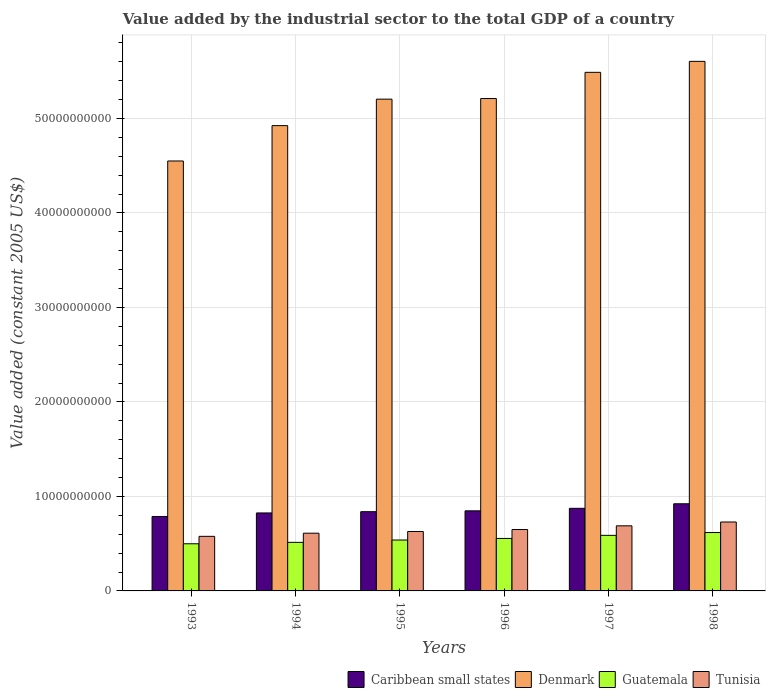How many groups of bars are there?
Provide a succinct answer. 6. Are the number of bars on each tick of the X-axis equal?
Provide a short and direct response. Yes. What is the label of the 2nd group of bars from the left?
Give a very brief answer. 1994. What is the value added by the industrial sector in Tunisia in 1998?
Give a very brief answer. 7.29e+09. Across all years, what is the maximum value added by the industrial sector in Guatemala?
Your response must be concise. 6.18e+09. Across all years, what is the minimum value added by the industrial sector in Guatemala?
Your response must be concise. 4.99e+09. In which year was the value added by the industrial sector in Tunisia maximum?
Give a very brief answer. 1998. What is the total value added by the industrial sector in Guatemala in the graph?
Your answer should be very brief. 3.31e+1. What is the difference between the value added by the industrial sector in Caribbean small states in 1994 and that in 1998?
Give a very brief answer. -9.70e+08. What is the difference between the value added by the industrial sector in Caribbean small states in 1994 and the value added by the industrial sector in Denmark in 1995?
Ensure brevity in your answer.  -4.38e+1. What is the average value added by the industrial sector in Tunisia per year?
Provide a short and direct response. 6.48e+09. In the year 1994, what is the difference between the value added by the industrial sector in Tunisia and value added by the industrial sector in Guatemala?
Ensure brevity in your answer.  9.70e+08. In how many years, is the value added by the industrial sector in Caribbean small states greater than 18000000000 US$?
Your response must be concise. 0. What is the ratio of the value added by the industrial sector in Tunisia in 1994 to that in 1997?
Offer a very short reply. 0.89. Is the value added by the industrial sector in Caribbean small states in 1994 less than that in 1995?
Offer a very short reply. Yes. Is the difference between the value added by the industrial sector in Tunisia in 1994 and 1995 greater than the difference between the value added by the industrial sector in Guatemala in 1994 and 1995?
Make the answer very short. Yes. What is the difference between the highest and the second highest value added by the industrial sector in Caribbean small states?
Ensure brevity in your answer.  4.80e+08. What is the difference between the highest and the lowest value added by the industrial sector in Guatemala?
Your answer should be compact. 1.19e+09. Is the sum of the value added by the industrial sector in Caribbean small states in 1995 and 1996 greater than the maximum value added by the industrial sector in Guatemala across all years?
Ensure brevity in your answer.  Yes. Is it the case that in every year, the sum of the value added by the industrial sector in Denmark and value added by the industrial sector in Guatemala is greater than the sum of value added by the industrial sector in Tunisia and value added by the industrial sector in Caribbean small states?
Give a very brief answer. Yes. What does the 1st bar from the left in 1993 represents?
Ensure brevity in your answer.  Caribbean small states. Is it the case that in every year, the sum of the value added by the industrial sector in Guatemala and value added by the industrial sector in Caribbean small states is greater than the value added by the industrial sector in Denmark?
Ensure brevity in your answer.  No. How many bars are there?
Your answer should be very brief. 24. What is the difference between two consecutive major ticks on the Y-axis?
Ensure brevity in your answer.  1.00e+1. How are the legend labels stacked?
Give a very brief answer. Horizontal. What is the title of the graph?
Your response must be concise. Value added by the industrial sector to the total GDP of a country. What is the label or title of the X-axis?
Keep it short and to the point. Years. What is the label or title of the Y-axis?
Keep it short and to the point. Value added (constant 2005 US$). What is the Value added (constant 2005 US$) of Caribbean small states in 1993?
Your answer should be very brief. 7.88e+09. What is the Value added (constant 2005 US$) in Denmark in 1993?
Your answer should be very brief. 4.55e+1. What is the Value added (constant 2005 US$) of Guatemala in 1993?
Make the answer very short. 4.99e+09. What is the Value added (constant 2005 US$) in Tunisia in 1993?
Your answer should be compact. 5.78e+09. What is the Value added (constant 2005 US$) of Caribbean small states in 1994?
Offer a very short reply. 8.25e+09. What is the Value added (constant 2005 US$) in Denmark in 1994?
Offer a very short reply. 4.92e+1. What is the Value added (constant 2005 US$) in Guatemala in 1994?
Offer a terse response. 5.14e+09. What is the Value added (constant 2005 US$) of Tunisia in 1994?
Ensure brevity in your answer.  6.11e+09. What is the Value added (constant 2005 US$) in Caribbean small states in 1995?
Keep it short and to the point. 8.38e+09. What is the Value added (constant 2005 US$) of Denmark in 1995?
Ensure brevity in your answer.  5.20e+1. What is the Value added (constant 2005 US$) in Guatemala in 1995?
Offer a very short reply. 5.39e+09. What is the Value added (constant 2005 US$) in Tunisia in 1995?
Provide a short and direct response. 6.29e+09. What is the Value added (constant 2005 US$) of Caribbean small states in 1996?
Offer a terse response. 8.48e+09. What is the Value added (constant 2005 US$) of Denmark in 1996?
Your response must be concise. 5.21e+1. What is the Value added (constant 2005 US$) in Guatemala in 1996?
Provide a short and direct response. 5.55e+09. What is the Value added (constant 2005 US$) in Tunisia in 1996?
Provide a succinct answer. 6.50e+09. What is the Value added (constant 2005 US$) in Caribbean small states in 1997?
Keep it short and to the point. 8.74e+09. What is the Value added (constant 2005 US$) of Denmark in 1997?
Keep it short and to the point. 5.49e+1. What is the Value added (constant 2005 US$) of Guatemala in 1997?
Give a very brief answer. 5.88e+09. What is the Value added (constant 2005 US$) of Tunisia in 1997?
Give a very brief answer. 6.89e+09. What is the Value added (constant 2005 US$) in Caribbean small states in 1998?
Give a very brief answer. 9.22e+09. What is the Value added (constant 2005 US$) of Denmark in 1998?
Offer a terse response. 5.60e+1. What is the Value added (constant 2005 US$) of Guatemala in 1998?
Your answer should be very brief. 6.18e+09. What is the Value added (constant 2005 US$) in Tunisia in 1998?
Provide a succinct answer. 7.29e+09. Across all years, what is the maximum Value added (constant 2005 US$) of Caribbean small states?
Offer a very short reply. 9.22e+09. Across all years, what is the maximum Value added (constant 2005 US$) of Denmark?
Make the answer very short. 5.60e+1. Across all years, what is the maximum Value added (constant 2005 US$) of Guatemala?
Your response must be concise. 6.18e+09. Across all years, what is the maximum Value added (constant 2005 US$) of Tunisia?
Your answer should be compact. 7.29e+09. Across all years, what is the minimum Value added (constant 2005 US$) of Caribbean small states?
Make the answer very short. 7.88e+09. Across all years, what is the minimum Value added (constant 2005 US$) in Denmark?
Provide a succinct answer. 4.55e+1. Across all years, what is the minimum Value added (constant 2005 US$) in Guatemala?
Offer a very short reply. 4.99e+09. Across all years, what is the minimum Value added (constant 2005 US$) in Tunisia?
Keep it short and to the point. 5.78e+09. What is the total Value added (constant 2005 US$) in Caribbean small states in the graph?
Offer a terse response. 5.10e+1. What is the total Value added (constant 2005 US$) of Denmark in the graph?
Provide a succinct answer. 3.10e+11. What is the total Value added (constant 2005 US$) of Guatemala in the graph?
Ensure brevity in your answer.  3.31e+1. What is the total Value added (constant 2005 US$) of Tunisia in the graph?
Keep it short and to the point. 3.89e+1. What is the difference between the Value added (constant 2005 US$) in Caribbean small states in 1993 and that in 1994?
Ensure brevity in your answer.  -3.73e+08. What is the difference between the Value added (constant 2005 US$) in Denmark in 1993 and that in 1994?
Make the answer very short. -3.74e+09. What is the difference between the Value added (constant 2005 US$) in Guatemala in 1993 and that in 1994?
Give a very brief answer. -1.51e+08. What is the difference between the Value added (constant 2005 US$) in Tunisia in 1993 and that in 1994?
Provide a succinct answer. -3.32e+08. What is the difference between the Value added (constant 2005 US$) in Caribbean small states in 1993 and that in 1995?
Provide a succinct answer. -5.06e+08. What is the difference between the Value added (constant 2005 US$) of Denmark in 1993 and that in 1995?
Provide a succinct answer. -6.54e+09. What is the difference between the Value added (constant 2005 US$) in Guatemala in 1993 and that in 1995?
Keep it short and to the point. -3.98e+08. What is the difference between the Value added (constant 2005 US$) in Tunisia in 1993 and that in 1995?
Your answer should be compact. -5.12e+08. What is the difference between the Value added (constant 2005 US$) of Caribbean small states in 1993 and that in 1996?
Provide a succinct answer. -5.97e+08. What is the difference between the Value added (constant 2005 US$) of Denmark in 1993 and that in 1996?
Your response must be concise. -6.61e+09. What is the difference between the Value added (constant 2005 US$) of Guatemala in 1993 and that in 1996?
Provide a short and direct response. -5.64e+08. What is the difference between the Value added (constant 2005 US$) of Tunisia in 1993 and that in 1996?
Your answer should be very brief. -7.22e+08. What is the difference between the Value added (constant 2005 US$) in Caribbean small states in 1993 and that in 1997?
Ensure brevity in your answer.  -8.63e+08. What is the difference between the Value added (constant 2005 US$) in Denmark in 1993 and that in 1997?
Offer a terse response. -9.38e+09. What is the difference between the Value added (constant 2005 US$) in Guatemala in 1993 and that in 1997?
Your answer should be very brief. -8.92e+08. What is the difference between the Value added (constant 2005 US$) of Tunisia in 1993 and that in 1997?
Your answer should be very brief. -1.11e+09. What is the difference between the Value added (constant 2005 US$) of Caribbean small states in 1993 and that in 1998?
Offer a terse response. -1.34e+09. What is the difference between the Value added (constant 2005 US$) of Denmark in 1993 and that in 1998?
Make the answer very short. -1.05e+1. What is the difference between the Value added (constant 2005 US$) in Guatemala in 1993 and that in 1998?
Offer a very short reply. -1.19e+09. What is the difference between the Value added (constant 2005 US$) of Tunisia in 1993 and that in 1998?
Your answer should be very brief. -1.52e+09. What is the difference between the Value added (constant 2005 US$) in Caribbean small states in 1994 and that in 1995?
Offer a terse response. -1.33e+08. What is the difference between the Value added (constant 2005 US$) in Denmark in 1994 and that in 1995?
Your answer should be very brief. -2.80e+09. What is the difference between the Value added (constant 2005 US$) of Guatemala in 1994 and that in 1995?
Offer a terse response. -2.48e+08. What is the difference between the Value added (constant 2005 US$) of Tunisia in 1994 and that in 1995?
Give a very brief answer. -1.80e+08. What is the difference between the Value added (constant 2005 US$) of Caribbean small states in 1994 and that in 1996?
Offer a very short reply. -2.24e+08. What is the difference between the Value added (constant 2005 US$) in Denmark in 1994 and that in 1996?
Ensure brevity in your answer.  -2.87e+09. What is the difference between the Value added (constant 2005 US$) of Guatemala in 1994 and that in 1996?
Your answer should be compact. -4.14e+08. What is the difference between the Value added (constant 2005 US$) in Tunisia in 1994 and that in 1996?
Your answer should be compact. -3.90e+08. What is the difference between the Value added (constant 2005 US$) in Caribbean small states in 1994 and that in 1997?
Offer a terse response. -4.90e+08. What is the difference between the Value added (constant 2005 US$) in Denmark in 1994 and that in 1997?
Keep it short and to the point. -5.64e+09. What is the difference between the Value added (constant 2005 US$) in Guatemala in 1994 and that in 1997?
Keep it short and to the point. -7.41e+08. What is the difference between the Value added (constant 2005 US$) in Tunisia in 1994 and that in 1997?
Your response must be concise. -7.79e+08. What is the difference between the Value added (constant 2005 US$) of Caribbean small states in 1994 and that in 1998?
Keep it short and to the point. -9.70e+08. What is the difference between the Value added (constant 2005 US$) in Denmark in 1994 and that in 1998?
Provide a succinct answer. -6.80e+09. What is the difference between the Value added (constant 2005 US$) in Guatemala in 1994 and that in 1998?
Give a very brief answer. -1.04e+09. What is the difference between the Value added (constant 2005 US$) of Tunisia in 1994 and that in 1998?
Offer a terse response. -1.19e+09. What is the difference between the Value added (constant 2005 US$) in Caribbean small states in 1995 and that in 1996?
Ensure brevity in your answer.  -9.07e+07. What is the difference between the Value added (constant 2005 US$) in Denmark in 1995 and that in 1996?
Offer a terse response. -6.66e+07. What is the difference between the Value added (constant 2005 US$) of Guatemala in 1995 and that in 1996?
Give a very brief answer. -1.66e+08. What is the difference between the Value added (constant 2005 US$) in Tunisia in 1995 and that in 1996?
Provide a short and direct response. -2.10e+08. What is the difference between the Value added (constant 2005 US$) of Caribbean small states in 1995 and that in 1997?
Your response must be concise. -3.57e+08. What is the difference between the Value added (constant 2005 US$) in Denmark in 1995 and that in 1997?
Your answer should be compact. -2.84e+09. What is the difference between the Value added (constant 2005 US$) in Guatemala in 1995 and that in 1997?
Provide a succinct answer. -4.93e+08. What is the difference between the Value added (constant 2005 US$) in Tunisia in 1995 and that in 1997?
Provide a succinct answer. -6.00e+08. What is the difference between the Value added (constant 2005 US$) in Caribbean small states in 1995 and that in 1998?
Provide a succinct answer. -8.37e+08. What is the difference between the Value added (constant 2005 US$) of Denmark in 1995 and that in 1998?
Give a very brief answer. -4.00e+09. What is the difference between the Value added (constant 2005 US$) in Guatemala in 1995 and that in 1998?
Make the answer very short. -7.93e+08. What is the difference between the Value added (constant 2005 US$) in Tunisia in 1995 and that in 1998?
Provide a succinct answer. -1.01e+09. What is the difference between the Value added (constant 2005 US$) of Caribbean small states in 1996 and that in 1997?
Your answer should be very brief. -2.66e+08. What is the difference between the Value added (constant 2005 US$) of Denmark in 1996 and that in 1997?
Ensure brevity in your answer.  -2.77e+09. What is the difference between the Value added (constant 2005 US$) in Guatemala in 1996 and that in 1997?
Offer a very short reply. -3.27e+08. What is the difference between the Value added (constant 2005 US$) of Tunisia in 1996 and that in 1997?
Ensure brevity in your answer.  -3.89e+08. What is the difference between the Value added (constant 2005 US$) of Caribbean small states in 1996 and that in 1998?
Provide a succinct answer. -7.46e+08. What is the difference between the Value added (constant 2005 US$) of Denmark in 1996 and that in 1998?
Offer a terse response. -3.93e+09. What is the difference between the Value added (constant 2005 US$) of Guatemala in 1996 and that in 1998?
Your answer should be compact. -6.27e+08. What is the difference between the Value added (constant 2005 US$) in Tunisia in 1996 and that in 1998?
Keep it short and to the point. -7.95e+08. What is the difference between the Value added (constant 2005 US$) in Caribbean small states in 1997 and that in 1998?
Your answer should be very brief. -4.80e+08. What is the difference between the Value added (constant 2005 US$) in Denmark in 1997 and that in 1998?
Your response must be concise. -1.16e+09. What is the difference between the Value added (constant 2005 US$) in Guatemala in 1997 and that in 1998?
Ensure brevity in your answer.  -3.00e+08. What is the difference between the Value added (constant 2005 US$) of Tunisia in 1997 and that in 1998?
Provide a short and direct response. -4.06e+08. What is the difference between the Value added (constant 2005 US$) of Caribbean small states in 1993 and the Value added (constant 2005 US$) of Denmark in 1994?
Offer a very short reply. -4.14e+1. What is the difference between the Value added (constant 2005 US$) of Caribbean small states in 1993 and the Value added (constant 2005 US$) of Guatemala in 1994?
Offer a terse response. 2.74e+09. What is the difference between the Value added (constant 2005 US$) in Caribbean small states in 1993 and the Value added (constant 2005 US$) in Tunisia in 1994?
Offer a terse response. 1.77e+09. What is the difference between the Value added (constant 2005 US$) in Denmark in 1993 and the Value added (constant 2005 US$) in Guatemala in 1994?
Your answer should be compact. 4.04e+1. What is the difference between the Value added (constant 2005 US$) in Denmark in 1993 and the Value added (constant 2005 US$) in Tunisia in 1994?
Provide a short and direct response. 3.94e+1. What is the difference between the Value added (constant 2005 US$) in Guatemala in 1993 and the Value added (constant 2005 US$) in Tunisia in 1994?
Ensure brevity in your answer.  -1.12e+09. What is the difference between the Value added (constant 2005 US$) of Caribbean small states in 1993 and the Value added (constant 2005 US$) of Denmark in 1995?
Your response must be concise. -4.42e+1. What is the difference between the Value added (constant 2005 US$) in Caribbean small states in 1993 and the Value added (constant 2005 US$) in Guatemala in 1995?
Make the answer very short. 2.49e+09. What is the difference between the Value added (constant 2005 US$) in Caribbean small states in 1993 and the Value added (constant 2005 US$) in Tunisia in 1995?
Offer a very short reply. 1.59e+09. What is the difference between the Value added (constant 2005 US$) in Denmark in 1993 and the Value added (constant 2005 US$) in Guatemala in 1995?
Make the answer very short. 4.01e+1. What is the difference between the Value added (constant 2005 US$) of Denmark in 1993 and the Value added (constant 2005 US$) of Tunisia in 1995?
Your answer should be compact. 3.92e+1. What is the difference between the Value added (constant 2005 US$) in Guatemala in 1993 and the Value added (constant 2005 US$) in Tunisia in 1995?
Make the answer very short. -1.30e+09. What is the difference between the Value added (constant 2005 US$) of Caribbean small states in 1993 and the Value added (constant 2005 US$) of Denmark in 1996?
Your response must be concise. -4.42e+1. What is the difference between the Value added (constant 2005 US$) of Caribbean small states in 1993 and the Value added (constant 2005 US$) of Guatemala in 1996?
Make the answer very short. 2.33e+09. What is the difference between the Value added (constant 2005 US$) of Caribbean small states in 1993 and the Value added (constant 2005 US$) of Tunisia in 1996?
Keep it short and to the point. 1.38e+09. What is the difference between the Value added (constant 2005 US$) of Denmark in 1993 and the Value added (constant 2005 US$) of Guatemala in 1996?
Offer a terse response. 3.99e+1. What is the difference between the Value added (constant 2005 US$) in Denmark in 1993 and the Value added (constant 2005 US$) in Tunisia in 1996?
Your answer should be compact. 3.90e+1. What is the difference between the Value added (constant 2005 US$) in Guatemala in 1993 and the Value added (constant 2005 US$) in Tunisia in 1996?
Make the answer very short. -1.51e+09. What is the difference between the Value added (constant 2005 US$) in Caribbean small states in 1993 and the Value added (constant 2005 US$) in Denmark in 1997?
Provide a short and direct response. -4.70e+1. What is the difference between the Value added (constant 2005 US$) in Caribbean small states in 1993 and the Value added (constant 2005 US$) in Guatemala in 1997?
Offer a very short reply. 2.00e+09. What is the difference between the Value added (constant 2005 US$) of Caribbean small states in 1993 and the Value added (constant 2005 US$) of Tunisia in 1997?
Offer a terse response. 9.90e+08. What is the difference between the Value added (constant 2005 US$) in Denmark in 1993 and the Value added (constant 2005 US$) in Guatemala in 1997?
Your response must be concise. 3.96e+1. What is the difference between the Value added (constant 2005 US$) of Denmark in 1993 and the Value added (constant 2005 US$) of Tunisia in 1997?
Make the answer very short. 3.86e+1. What is the difference between the Value added (constant 2005 US$) of Guatemala in 1993 and the Value added (constant 2005 US$) of Tunisia in 1997?
Ensure brevity in your answer.  -1.90e+09. What is the difference between the Value added (constant 2005 US$) of Caribbean small states in 1993 and the Value added (constant 2005 US$) of Denmark in 1998?
Your response must be concise. -4.82e+1. What is the difference between the Value added (constant 2005 US$) in Caribbean small states in 1993 and the Value added (constant 2005 US$) in Guatemala in 1998?
Ensure brevity in your answer.  1.70e+09. What is the difference between the Value added (constant 2005 US$) of Caribbean small states in 1993 and the Value added (constant 2005 US$) of Tunisia in 1998?
Provide a succinct answer. 5.84e+08. What is the difference between the Value added (constant 2005 US$) in Denmark in 1993 and the Value added (constant 2005 US$) in Guatemala in 1998?
Make the answer very short. 3.93e+1. What is the difference between the Value added (constant 2005 US$) of Denmark in 1993 and the Value added (constant 2005 US$) of Tunisia in 1998?
Your answer should be very brief. 3.82e+1. What is the difference between the Value added (constant 2005 US$) in Guatemala in 1993 and the Value added (constant 2005 US$) in Tunisia in 1998?
Keep it short and to the point. -2.31e+09. What is the difference between the Value added (constant 2005 US$) of Caribbean small states in 1994 and the Value added (constant 2005 US$) of Denmark in 1995?
Keep it short and to the point. -4.38e+1. What is the difference between the Value added (constant 2005 US$) of Caribbean small states in 1994 and the Value added (constant 2005 US$) of Guatemala in 1995?
Your response must be concise. 2.86e+09. What is the difference between the Value added (constant 2005 US$) of Caribbean small states in 1994 and the Value added (constant 2005 US$) of Tunisia in 1995?
Provide a succinct answer. 1.96e+09. What is the difference between the Value added (constant 2005 US$) in Denmark in 1994 and the Value added (constant 2005 US$) in Guatemala in 1995?
Your answer should be compact. 4.39e+1. What is the difference between the Value added (constant 2005 US$) of Denmark in 1994 and the Value added (constant 2005 US$) of Tunisia in 1995?
Make the answer very short. 4.29e+1. What is the difference between the Value added (constant 2005 US$) of Guatemala in 1994 and the Value added (constant 2005 US$) of Tunisia in 1995?
Your answer should be compact. -1.15e+09. What is the difference between the Value added (constant 2005 US$) in Caribbean small states in 1994 and the Value added (constant 2005 US$) in Denmark in 1996?
Ensure brevity in your answer.  -4.39e+1. What is the difference between the Value added (constant 2005 US$) of Caribbean small states in 1994 and the Value added (constant 2005 US$) of Guatemala in 1996?
Your answer should be very brief. 2.70e+09. What is the difference between the Value added (constant 2005 US$) of Caribbean small states in 1994 and the Value added (constant 2005 US$) of Tunisia in 1996?
Offer a terse response. 1.75e+09. What is the difference between the Value added (constant 2005 US$) in Denmark in 1994 and the Value added (constant 2005 US$) in Guatemala in 1996?
Offer a very short reply. 4.37e+1. What is the difference between the Value added (constant 2005 US$) of Denmark in 1994 and the Value added (constant 2005 US$) of Tunisia in 1996?
Your response must be concise. 4.27e+1. What is the difference between the Value added (constant 2005 US$) in Guatemala in 1994 and the Value added (constant 2005 US$) in Tunisia in 1996?
Provide a short and direct response. -1.36e+09. What is the difference between the Value added (constant 2005 US$) in Caribbean small states in 1994 and the Value added (constant 2005 US$) in Denmark in 1997?
Your response must be concise. -4.66e+1. What is the difference between the Value added (constant 2005 US$) in Caribbean small states in 1994 and the Value added (constant 2005 US$) in Guatemala in 1997?
Your response must be concise. 2.37e+09. What is the difference between the Value added (constant 2005 US$) of Caribbean small states in 1994 and the Value added (constant 2005 US$) of Tunisia in 1997?
Keep it short and to the point. 1.36e+09. What is the difference between the Value added (constant 2005 US$) in Denmark in 1994 and the Value added (constant 2005 US$) in Guatemala in 1997?
Provide a succinct answer. 4.34e+1. What is the difference between the Value added (constant 2005 US$) in Denmark in 1994 and the Value added (constant 2005 US$) in Tunisia in 1997?
Offer a terse response. 4.23e+1. What is the difference between the Value added (constant 2005 US$) of Guatemala in 1994 and the Value added (constant 2005 US$) of Tunisia in 1997?
Give a very brief answer. -1.75e+09. What is the difference between the Value added (constant 2005 US$) in Caribbean small states in 1994 and the Value added (constant 2005 US$) in Denmark in 1998?
Your answer should be compact. -4.78e+1. What is the difference between the Value added (constant 2005 US$) in Caribbean small states in 1994 and the Value added (constant 2005 US$) in Guatemala in 1998?
Make the answer very short. 2.07e+09. What is the difference between the Value added (constant 2005 US$) of Caribbean small states in 1994 and the Value added (constant 2005 US$) of Tunisia in 1998?
Make the answer very short. 9.57e+08. What is the difference between the Value added (constant 2005 US$) in Denmark in 1994 and the Value added (constant 2005 US$) in Guatemala in 1998?
Give a very brief answer. 4.31e+1. What is the difference between the Value added (constant 2005 US$) in Denmark in 1994 and the Value added (constant 2005 US$) in Tunisia in 1998?
Make the answer very short. 4.19e+1. What is the difference between the Value added (constant 2005 US$) of Guatemala in 1994 and the Value added (constant 2005 US$) of Tunisia in 1998?
Your answer should be very brief. -2.16e+09. What is the difference between the Value added (constant 2005 US$) in Caribbean small states in 1995 and the Value added (constant 2005 US$) in Denmark in 1996?
Give a very brief answer. -4.37e+1. What is the difference between the Value added (constant 2005 US$) in Caribbean small states in 1995 and the Value added (constant 2005 US$) in Guatemala in 1996?
Your answer should be very brief. 2.83e+09. What is the difference between the Value added (constant 2005 US$) in Caribbean small states in 1995 and the Value added (constant 2005 US$) in Tunisia in 1996?
Offer a terse response. 1.89e+09. What is the difference between the Value added (constant 2005 US$) in Denmark in 1995 and the Value added (constant 2005 US$) in Guatemala in 1996?
Keep it short and to the point. 4.65e+1. What is the difference between the Value added (constant 2005 US$) in Denmark in 1995 and the Value added (constant 2005 US$) in Tunisia in 1996?
Ensure brevity in your answer.  4.55e+1. What is the difference between the Value added (constant 2005 US$) in Guatemala in 1995 and the Value added (constant 2005 US$) in Tunisia in 1996?
Your answer should be compact. -1.11e+09. What is the difference between the Value added (constant 2005 US$) in Caribbean small states in 1995 and the Value added (constant 2005 US$) in Denmark in 1997?
Give a very brief answer. -4.65e+1. What is the difference between the Value added (constant 2005 US$) of Caribbean small states in 1995 and the Value added (constant 2005 US$) of Guatemala in 1997?
Offer a very short reply. 2.50e+09. What is the difference between the Value added (constant 2005 US$) of Caribbean small states in 1995 and the Value added (constant 2005 US$) of Tunisia in 1997?
Offer a very short reply. 1.50e+09. What is the difference between the Value added (constant 2005 US$) of Denmark in 1995 and the Value added (constant 2005 US$) of Guatemala in 1997?
Offer a very short reply. 4.62e+1. What is the difference between the Value added (constant 2005 US$) of Denmark in 1995 and the Value added (constant 2005 US$) of Tunisia in 1997?
Offer a terse response. 4.51e+1. What is the difference between the Value added (constant 2005 US$) of Guatemala in 1995 and the Value added (constant 2005 US$) of Tunisia in 1997?
Your answer should be compact. -1.50e+09. What is the difference between the Value added (constant 2005 US$) in Caribbean small states in 1995 and the Value added (constant 2005 US$) in Denmark in 1998?
Your response must be concise. -4.77e+1. What is the difference between the Value added (constant 2005 US$) in Caribbean small states in 1995 and the Value added (constant 2005 US$) in Guatemala in 1998?
Offer a very short reply. 2.20e+09. What is the difference between the Value added (constant 2005 US$) of Caribbean small states in 1995 and the Value added (constant 2005 US$) of Tunisia in 1998?
Provide a succinct answer. 1.09e+09. What is the difference between the Value added (constant 2005 US$) in Denmark in 1995 and the Value added (constant 2005 US$) in Guatemala in 1998?
Offer a terse response. 4.59e+1. What is the difference between the Value added (constant 2005 US$) in Denmark in 1995 and the Value added (constant 2005 US$) in Tunisia in 1998?
Provide a short and direct response. 4.47e+1. What is the difference between the Value added (constant 2005 US$) of Guatemala in 1995 and the Value added (constant 2005 US$) of Tunisia in 1998?
Provide a succinct answer. -1.91e+09. What is the difference between the Value added (constant 2005 US$) of Caribbean small states in 1996 and the Value added (constant 2005 US$) of Denmark in 1997?
Offer a terse response. -4.64e+1. What is the difference between the Value added (constant 2005 US$) of Caribbean small states in 1996 and the Value added (constant 2005 US$) of Guatemala in 1997?
Your answer should be very brief. 2.60e+09. What is the difference between the Value added (constant 2005 US$) of Caribbean small states in 1996 and the Value added (constant 2005 US$) of Tunisia in 1997?
Your response must be concise. 1.59e+09. What is the difference between the Value added (constant 2005 US$) of Denmark in 1996 and the Value added (constant 2005 US$) of Guatemala in 1997?
Your answer should be compact. 4.62e+1. What is the difference between the Value added (constant 2005 US$) in Denmark in 1996 and the Value added (constant 2005 US$) in Tunisia in 1997?
Make the answer very short. 4.52e+1. What is the difference between the Value added (constant 2005 US$) in Guatemala in 1996 and the Value added (constant 2005 US$) in Tunisia in 1997?
Provide a short and direct response. -1.34e+09. What is the difference between the Value added (constant 2005 US$) of Caribbean small states in 1996 and the Value added (constant 2005 US$) of Denmark in 1998?
Offer a terse response. -4.76e+1. What is the difference between the Value added (constant 2005 US$) in Caribbean small states in 1996 and the Value added (constant 2005 US$) in Guatemala in 1998?
Your response must be concise. 2.30e+09. What is the difference between the Value added (constant 2005 US$) of Caribbean small states in 1996 and the Value added (constant 2005 US$) of Tunisia in 1998?
Your answer should be compact. 1.18e+09. What is the difference between the Value added (constant 2005 US$) in Denmark in 1996 and the Value added (constant 2005 US$) in Guatemala in 1998?
Your answer should be very brief. 4.59e+1. What is the difference between the Value added (constant 2005 US$) in Denmark in 1996 and the Value added (constant 2005 US$) in Tunisia in 1998?
Ensure brevity in your answer.  4.48e+1. What is the difference between the Value added (constant 2005 US$) in Guatemala in 1996 and the Value added (constant 2005 US$) in Tunisia in 1998?
Keep it short and to the point. -1.74e+09. What is the difference between the Value added (constant 2005 US$) in Caribbean small states in 1997 and the Value added (constant 2005 US$) in Denmark in 1998?
Make the answer very short. -4.73e+1. What is the difference between the Value added (constant 2005 US$) in Caribbean small states in 1997 and the Value added (constant 2005 US$) in Guatemala in 1998?
Keep it short and to the point. 2.56e+09. What is the difference between the Value added (constant 2005 US$) of Caribbean small states in 1997 and the Value added (constant 2005 US$) of Tunisia in 1998?
Give a very brief answer. 1.45e+09. What is the difference between the Value added (constant 2005 US$) of Denmark in 1997 and the Value added (constant 2005 US$) of Guatemala in 1998?
Offer a very short reply. 4.87e+1. What is the difference between the Value added (constant 2005 US$) of Denmark in 1997 and the Value added (constant 2005 US$) of Tunisia in 1998?
Offer a very short reply. 4.76e+1. What is the difference between the Value added (constant 2005 US$) of Guatemala in 1997 and the Value added (constant 2005 US$) of Tunisia in 1998?
Provide a succinct answer. -1.41e+09. What is the average Value added (constant 2005 US$) in Caribbean small states per year?
Provide a short and direct response. 8.49e+09. What is the average Value added (constant 2005 US$) in Denmark per year?
Offer a terse response. 5.16e+1. What is the average Value added (constant 2005 US$) in Guatemala per year?
Provide a short and direct response. 5.52e+09. What is the average Value added (constant 2005 US$) in Tunisia per year?
Make the answer very short. 6.48e+09. In the year 1993, what is the difference between the Value added (constant 2005 US$) of Caribbean small states and Value added (constant 2005 US$) of Denmark?
Give a very brief answer. -3.76e+1. In the year 1993, what is the difference between the Value added (constant 2005 US$) of Caribbean small states and Value added (constant 2005 US$) of Guatemala?
Your answer should be very brief. 2.89e+09. In the year 1993, what is the difference between the Value added (constant 2005 US$) in Caribbean small states and Value added (constant 2005 US$) in Tunisia?
Keep it short and to the point. 2.10e+09. In the year 1993, what is the difference between the Value added (constant 2005 US$) of Denmark and Value added (constant 2005 US$) of Guatemala?
Give a very brief answer. 4.05e+1. In the year 1993, what is the difference between the Value added (constant 2005 US$) in Denmark and Value added (constant 2005 US$) in Tunisia?
Your answer should be compact. 3.97e+1. In the year 1993, what is the difference between the Value added (constant 2005 US$) of Guatemala and Value added (constant 2005 US$) of Tunisia?
Your answer should be compact. -7.89e+08. In the year 1994, what is the difference between the Value added (constant 2005 US$) of Caribbean small states and Value added (constant 2005 US$) of Denmark?
Offer a terse response. -4.10e+1. In the year 1994, what is the difference between the Value added (constant 2005 US$) in Caribbean small states and Value added (constant 2005 US$) in Guatemala?
Provide a succinct answer. 3.11e+09. In the year 1994, what is the difference between the Value added (constant 2005 US$) in Caribbean small states and Value added (constant 2005 US$) in Tunisia?
Offer a very short reply. 2.14e+09. In the year 1994, what is the difference between the Value added (constant 2005 US$) in Denmark and Value added (constant 2005 US$) in Guatemala?
Make the answer very short. 4.41e+1. In the year 1994, what is the difference between the Value added (constant 2005 US$) in Denmark and Value added (constant 2005 US$) in Tunisia?
Keep it short and to the point. 4.31e+1. In the year 1994, what is the difference between the Value added (constant 2005 US$) of Guatemala and Value added (constant 2005 US$) of Tunisia?
Offer a terse response. -9.70e+08. In the year 1995, what is the difference between the Value added (constant 2005 US$) of Caribbean small states and Value added (constant 2005 US$) of Denmark?
Keep it short and to the point. -4.37e+1. In the year 1995, what is the difference between the Value added (constant 2005 US$) in Caribbean small states and Value added (constant 2005 US$) in Guatemala?
Provide a short and direct response. 3.00e+09. In the year 1995, what is the difference between the Value added (constant 2005 US$) in Caribbean small states and Value added (constant 2005 US$) in Tunisia?
Provide a short and direct response. 2.10e+09. In the year 1995, what is the difference between the Value added (constant 2005 US$) of Denmark and Value added (constant 2005 US$) of Guatemala?
Your response must be concise. 4.67e+1. In the year 1995, what is the difference between the Value added (constant 2005 US$) in Denmark and Value added (constant 2005 US$) in Tunisia?
Your answer should be very brief. 4.57e+1. In the year 1995, what is the difference between the Value added (constant 2005 US$) of Guatemala and Value added (constant 2005 US$) of Tunisia?
Ensure brevity in your answer.  -9.02e+08. In the year 1996, what is the difference between the Value added (constant 2005 US$) in Caribbean small states and Value added (constant 2005 US$) in Denmark?
Give a very brief answer. -4.36e+1. In the year 1996, what is the difference between the Value added (constant 2005 US$) in Caribbean small states and Value added (constant 2005 US$) in Guatemala?
Offer a very short reply. 2.92e+09. In the year 1996, what is the difference between the Value added (constant 2005 US$) in Caribbean small states and Value added (constant 2005 US$) in Tunisia?
Your answer should be compact. 1.98e+09. In the year 1996, what is the difference between the Value added (constant 2005 US$) of Denmark and Value added (constant 2005 US$) of Guatemala?
Offer a very short reply. 4.66e+1. In the year 1996, what is the difference between the Value added (constant 2005 US$) in Denmark and Value added (constant 2005 US$) in Tunisia?
Keep it short and to the point. 4.56e+1. In the year 1996, what is the difference between the Value added (constant 2005 US$) of Guatemala and Value added (constant 2005 US$) of Tunisia?
Provide a succinct answer. -9.47e+08. In the year 1997, what is the difference between the Value added (constant 2005 US$) in Caribbean small states and Value added (constant 2005 US$) in Denmark?
Offer a very short reply. -4.61e+1. In the year 1997, what is the difference between the Value added (constant 2005 US$) in Caribbean small states and Value added (constant 2005 US$) in Guatemala?
Your response must be concise. 2.86e+09. In the year 1997, what is the difference between the Value added (constant 2005 US$) of Caribbean small states and Value added (constant 2005 US$) of Tunisia?
Your answer should be very brief. 1.85e+09. In the year 1997, what is the difference between the Value added (constant 2005 US$) in Denmark and Value added (constant 2005 US$) in Guatemala?
Offer a terse response. 4.90e+1. In the year 1997, what is the difference between the Value added (constant 2005 US$) of Denmark and Value added (constant 2005 US$) of Tunisia?
Keep it short and to the point. 4.80e+1. In the year 1997, what is the difference between the Value added (constant 2005 US$) of Guatemala and Value added (constant 2005 US$) of Tunisia?
Provide a short and direct response. -1.01e+09. In the year 1998, what is the difference between the Value added (constant 2005 US$) of Caribbean small states and Value added (constant 2005 US$) of Denmark?
Your response must be concise. -4.68e+1. In the year 1998, what is the difference between the Value added (constant 2005 US$) in Caribbean small states and Value added (constant 2005 US$) in Guatemala?
Keep it short and to the point. 3.04e+09. In the year 1998, what is the difference between the Value added (constant 2005 US$) in Caribbean small states and Value added (constant 2005 US$) in Tunisia?
Offer a terse response. 1.93e+09. In the year 1998, what is the difference between the Value added (constant 2005 US$) of Denmark and Value added (constant 2005 US$) of Guatemala?
Give a very brief answer. 4.99e+1. In the year 1998, what is the difference between the Value added (constant 2005 US$) in Denmark and Value added (constant 2005 US$) in Tunisia?
Provide a succinct answer. 4.87e+1. In the year 1998, what is the difference between the Value added (constant 2005 US$) of Guatemala and Value added (constant 2005 US$) of Tunisia?
Offer a terse response. -1.11e+09. What is the ratio of the Value added (constant 2005 US$) in Caribbean small states in 1993 to that in 1994?
Make the answer very short. 0.95. What is the ratio of the Value added (constant 2005 US$) of Denmark in 1993 to that in 1994?
Provide a short and direct response. 0.92. What is the ratio of the Value added (constant 2005 US$) of Guatemala in 1993 to that in 1994?
Your response must be concise. 0.97. What is the ratio of the Value added (constant 2005 US$) in Tunisia in 1993 to that in 1994?
Your answer should be very brief. 0.95. What is the ratio of the Value added (constant 2005 US$) of Caribbean small states in 1993 to that in 1995?
Offer a terse response. 0.94. What is the ratio of the Value added (constant 2005 US$) of Denmark in 1993 to that in 1995?
Give a very brief answer. 0.87. What is the ratio of the Value added (constant 2005 US$) of Guatemala in 1993 to that in 1995?
Your response must be concise. 0.93. What is the ratio of the Value added (constant 2005 US$) in Tunisia in 1993 to that in 1995?
Give a very brief answer. 0.92. What is the ratio of the Value added (constant 2005 US$) in Caribbean small states in 1993 to that in 1996?
Your answer should be compact. 0.93. What is the ratio of the Value added (constant 2005 US$) in Denmark in 1993 to that in 1996?
Ensure brevity in your answer.  0.87. What is the ratio of the Value added (constant 2005 US$) in Guatemala in 1993 to that in 1996?
Your response must be concise. 0.9. What is the ratio of the Value added (constant 2005 US$) in Tunisia in 1993 to that in 1996?
Your answer should be very brief. 0.89. What is the ratio of the Value added (constant 2005 US$) of Caribbean small states in 1993 to that in 1997?
Offer a terse response. 0.9. What is the ratio of the Value added (constant 2005 US$) of Denmark in 1993 to that in 1997?
Ensure brevity in your answer.  0.83. What is the ratio of the Value added (constant 2005 US$) of Guatemala in 1993 to that in 1997?
Provide a short and direct response. 0.85. What is the ratio of the Value added (constant 2005 US$) in Tunisia in 1993 to that in 1997?
Your answer should be compact. 0.84. What is the ratio of the Value added (constant 2005 US$) of Caribbean small states in 1993 to that in 1998?
Provide a short and direct response. 0.85. What is the ratio of the Value added (constant 2005 US$) in Denmark in 1993 to that in 1998?
Your response must be concise. 0.81. What is the ratio of the Value added (constant 2005 US$) in Guatemala in 1993 to that in 1998?
Offer a terse response. 0.81. What is the ratio of the Value added (constant 2005 US$) in Tunisia in 1993 to that in 1998?
Your answer should be compact. 0.79. What is the ratio of the Value added (constant 2005 US$) of Caribbean small states in 1994 to that in 1995?
Keep it short and to the point. 0.98. What is the ratio of the Value added (constant 2005 US$) of Denmark in 1994 to that in 1995?
Offer a very short reply. 0.95. What is the ratio of the Value added (constant 2005 US$) of Guatemala in 1994 to that in 1995?
Ensure brevity in your answer.  0.95. What is the ratio of the Value added (constant 2005 US$) in Tunisia in 1994 to that in 1995?
Provide a succinct answer. 0.97. What is the ratio of the Value added (constant 2005 US$) of Caribbean small states in 1994 to that in 1996?
Provide a short and direct response. 0.97. What is the ratio of the Value added (constant 2005 US$) in Denmark in 1994 to that in 1996?
Ensure brevity in your answer.  0.94. What is the ratio of the Value added (constant 2005 US$) in Guatemala in 1994 to that in 1996?
Offer a very short reply. 0.93. What is the ratio of the Value added (constant 2005 US$) in Tunisia in 1994 to that in 1996?
Give a very brief answer. 0.94. What is the ratio of the Value added (constant 2005 US$) of Caribbean small states in 1994 to that in 1997?
Offer a very short reply. 0.94. What is the ratio of the Value added (constant 2005 US$) of Denmark in 1994 to that in 1997?
Provide a succinct answer. 0.9. What is the ratio of the Value added (constant 2005 US$) in Guatemala in 1994 to that in 1997?
Provide a short and direct response. 0.87. What is the ratio of the Value added (constant 2005 US$) in Tunisia in 1994 to that in 1997?
Give a very brief answer. 0.89. What is the ratio of the Value added (constant 2005 US$) of Caribbean small states in 1994 to that in 1998?
Give a very brief answer. 0.89. What is the ratio of the Value added (constant 2005 US$) of Denmark in 1994 to that in 1998?
Offer a terse response. 0.88. What is the ratio of the Value added (constant 2005 US$) of Guatemala in 1994 to that in 1998?
Make the answer very short. 0.83. What is the ratio of the Value added (constant 2005 US$) of Tunisia in 1994 to that in 1998?
Give a very brief answer. 0.84. What is the ratio of the Value added (constant 2005 US$) of Caribbean small states in 1995 to that in 1996?
Make the answer very short. 0.99. What is the ratio of the Value added (constant 2005 US$) of Guatemala in 1995 to that in 1996?
Your answer should be compact. 0.97. What is the ratio of the Value added (constant 2005 US$) in Tunisia in 1995 to that in 1996?
Offer a terse response. 0.97. What is the ratio of the Value added (constant 2005 US$) in Caribbean small states in 1995 to that in 1997?
Ensure brevity in your answer.  0.96. What is the ratio of the Value added (constant 2005 US$) of Denmark in 1995 to that in 1997?
Offer a very short reply. 0.95. What is the ratio of the Value added (constant 2005 US$) in Guatemala in 1995 to that in 1997?
Your response must be concise. 0.92. What is the ratio of the Value added (constant 2005 US$) in Tunisia in 1995 to that in 1997?
Your answer should be compact. 0.91. What is the ratio of the Value added (constant 2005 US$) in Caribbean small states in 1995 to that in 1998?
Provide a succinct answer. 0.91. What is the ratio of the Value added (constant 2005 US$) in Guatemala in 1995 to that in 1998?
Provide a short and direct response. 0.87. What is the ratio of the Value added (constant 2005 US$) of Tunisia in 1995 to that in 1998?
Your answer should be very brief. 0.86. What is the ratio of the Value added (constant 2005 US$) in Caribbean small states in 1996 to that in 1997?
Offer a terse response. 0.97. What is the ratio of the Value added (constant 2005 US$) in Denmark in 1996 to that in 1997?
Keep it short and to the point. 0.95. What is the ratio of the Value added (constant 2005 US$) in Guatemala in 1996 to that in 1997?
Ensure brevity in your answer.  0.94. What is the ratio of the Value added (constant 2005 US$) in Tunisia in 1996 to that in 1997?
Provide a short and direct response. 0.94. What is the ratio of the Value added (constant 2005 US$) of Caribbean small states in 1996 to that in 1998?
Your answer should be very brief. 0.92. What is the ratio of the Value added (constant 2005 US$) in Denmark in 1996 to that in 1998?
Provide a short and direct response. 0.93. What is the ratio of the Value added (constant 2005 US$) in Guatemala in 1996 to that in 1998?
Your answer should be compact. 0.9. What is the ratio of the Value added (constant 2005 US$) of Tunisia in 1996 to that in 1998?
Your response must be concise. 0.89. What is the ratio of the Value added (constant 2005 US$) in Caribbean small states in 1997 to that in 1998?
Give a very brief answer. 0.95. What is the ratio of the Value added (constant 2005 US$) of Denmark in 1997 to that in 1998?
Ensure brevity in your answer.  0.98. What is the ratio of the Value added (constant 2005 US$) of Guatemala in 1997 to that in 1998?
Your answer should be very brief. 0.95. What is the ratio of the Value added (constant 2005 US$) in Tunisia in 1997 to that in 1998?
Offer a very short reply. 0.94. What is the difference between the highest and the second highest Value added (constant 2005 US$) in Caribbean small states?
Offer a terse response. 4.80e+08. What is the difference between the highest and the second highest Value added (constant 2005 US$) of Denmark?
Make the answer very short. 1.16e+09. What is the difference between the highest and the second highest Value added (constant 2005 US$) of Guatemala?
Your response must be concise. 3.00e+08. What is the difference between the highest and the second highest Value added (constant 2005 US$) in Tunisia?
Keep it short and to the point. 4.06e+08. What is the difference between the highest and the lowest Value added (constant 2005 US$) in Caribbean small states?
Provide a succinct answer. 1.34e+09. What is the difference between the highest and the lowest Value added (constant 2005 US$) in Denmark?
Your answer should be compact. 1.05e+1. What is the difference between the highest and the lowest Value added (constant 2005 US$) in Guatemala?
Your response must be concise. 1.19e+09. What is the difference between the highest and the lowest Value added (constant 2005 US$) of Tunisia?
Provide a succinct answer. 1.52e+09. 